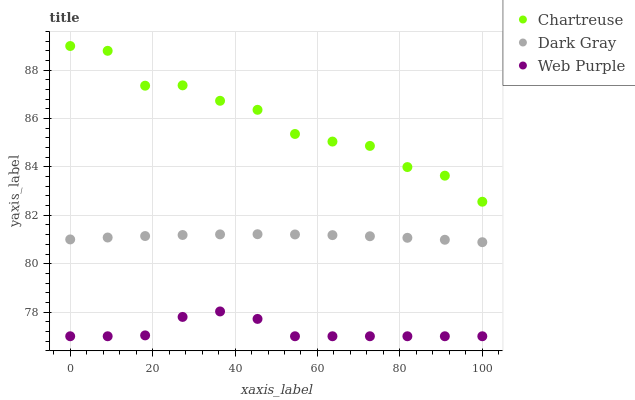Does Web Purple have the minimum area under the curve?
Answer yes or no. Yes. Does Chartreuse have the maximum area under the curve?
Answer yes or no. Yes. Does Chartreuse have the minimum area under the curve?
Answer yes or no. No. Does Web Purple have the maximum area under the curve?
Answer yes or no. No. Is Dark Gray the smoothest?
Answer yes or no. Yes. Is Chartreuse the roughest?
Answer yes or no. Yes. Is Web Purple the smoothest?
Answer yes or no. No. Is Web Purple the roughest?
Answer yes or no. No. Does Web Purple have the lowest value?
Answer yes or no. Yes. Does Chartreuse have the lowest value?
Answer yes or no. No. Does Chartreuse have the highest value?
Answer yes or no. Yes. Does Web Purple have the highest value?
Answer yes or no. No. Is Web Purple less than Dark Gray?
Answer yes or no. Yes. Is Chartreuse greater than Dark Gray?
Answer yes or no. Yes. Does Web Purple intersect Dark Gray?
Answer yes or no. No. 